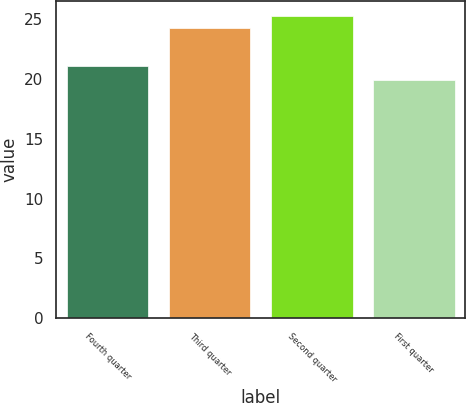<chart> <loc_0><loc_0><loc_500><loc_500><bar_chart><fcel>Fourth quarter<fcel>Third quarter<fcel>Second quarter<fcel>First quarter<nl><fcel>21.13<fcel>24.25<fcel>25.3<fcel>19.92<nl></chart> 